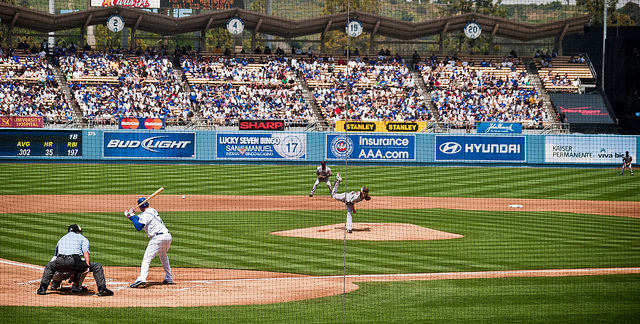Please transcribe the text in this image. insurance HUNNDAI AAA.com STANLEY STANLEY PERMANENTE 17 SHARP SEVEN LUCKY LIGHT BUD 18 302 35 197 MA AVG 2 2 